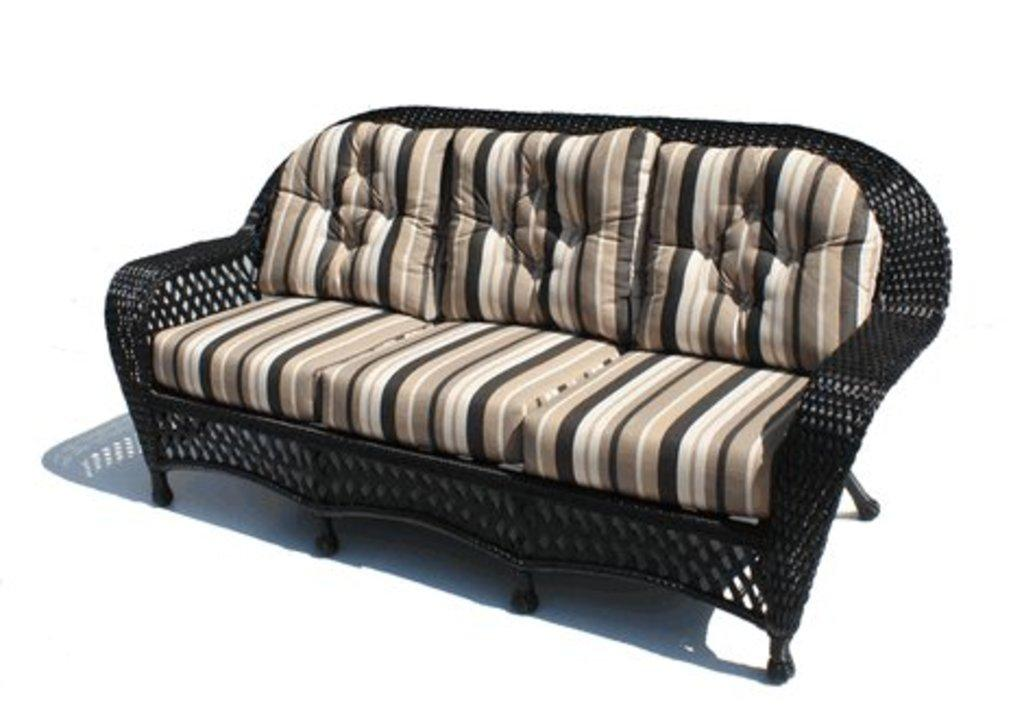What color is the main part of the sofa in the image? The main part of the sofa in the image is black-colored. What colors are the seats of the sofa? The seats of the sofa are brown and cream-colored. What color is the background of the image? The background of the image is white. How many heads of lettuce can be seen growing in the image? There are no heads of lettuce present in the image. What type of bushes are visible in the background of the image? There are no bushes visible in the image, as the background is white. 